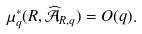Convert formula to latex. <formula><loc_0><loc_0><loc_500><loc_500>\mu _ { q } ^ { \ast } ( R , \widehat { \mathcal { A } } _ { R , q } ) = O ( q ) .</formula> 